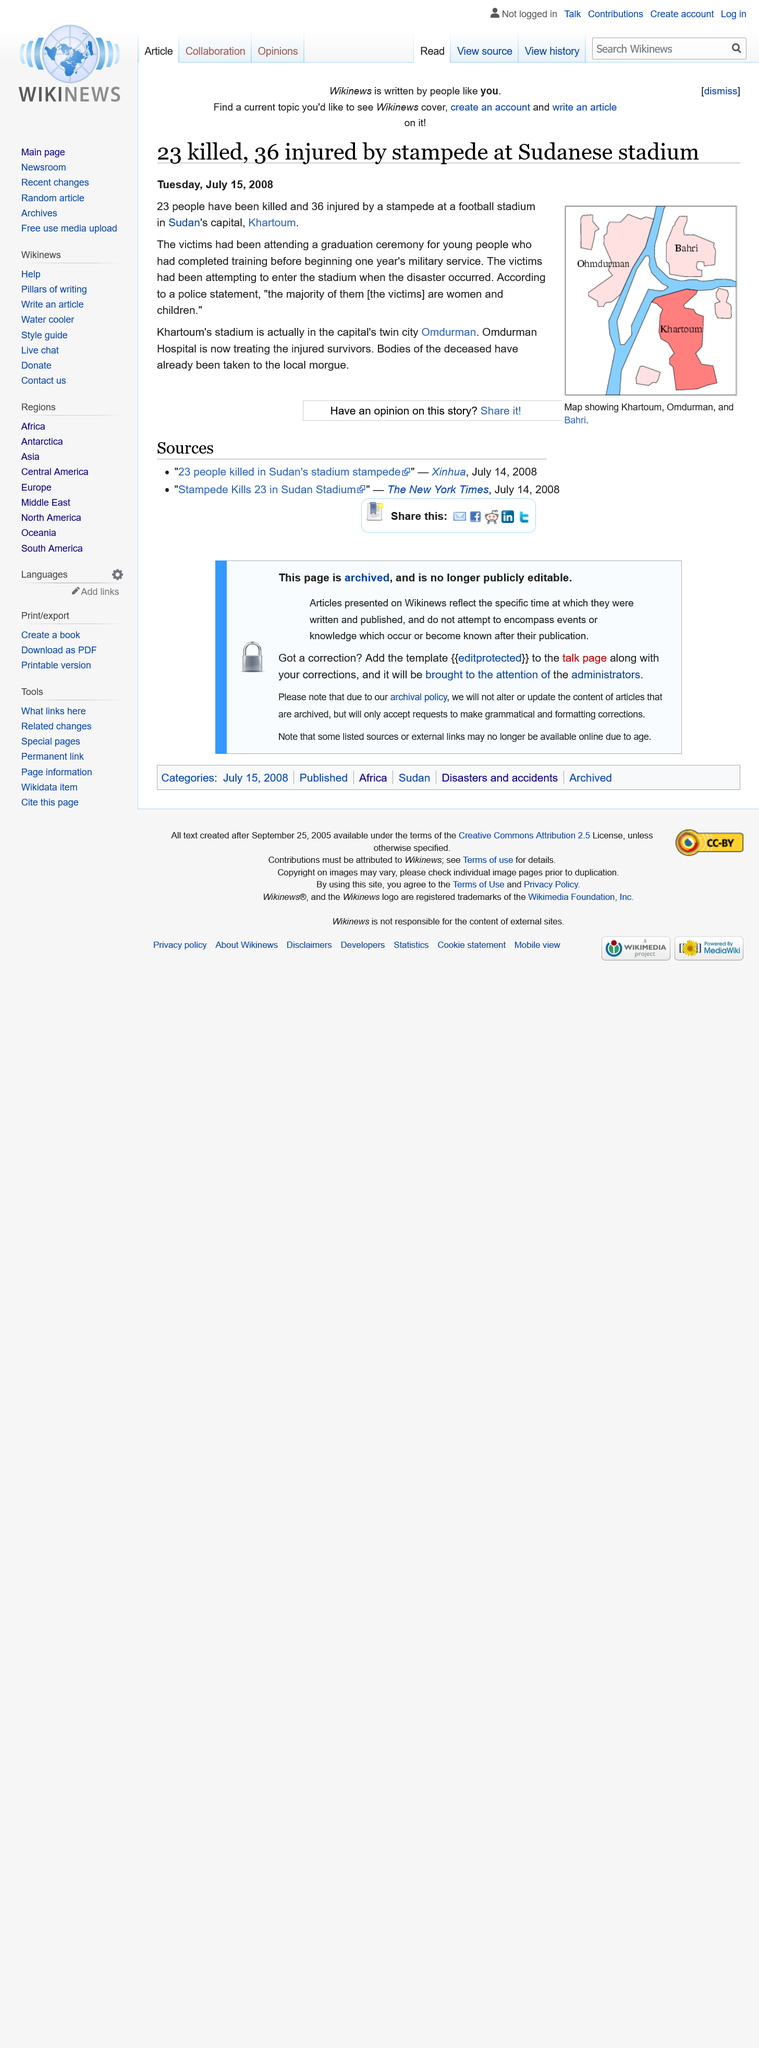Mention a couple of crucial points in this snapshot. The speaker states that the incident occurred in Sudan, specifically in Khartoum, which is the capital of Sudan. Thirty-six people were injured. Approximately 23 people were killed. 